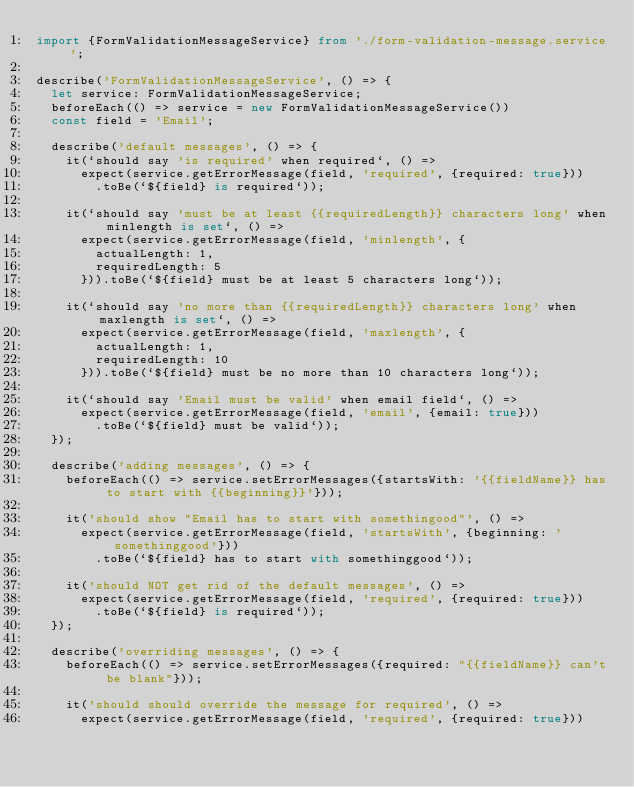<code> <loc_0><loc_0><loc_500><loc_500><_TypeScript_>import {FormValidationMessageService} from './form-validation-message.service';

describe('FormValidationMessageService', () => {
  let service: FormValidationMessageService;
  beforeEach(() => service = new FormValidationMessageService())
  const field = 'Email';

  describe('default messages', () => {
    it(`should say 'is required' when required`, () =>
      expect(service.getErrorMessage(field, 'required', {required: true}))
        .toBe(`${field} is required`));

    it(`should say 'must be at least {{requiredLength}} characters long' when minlength is set`, () =>
      expect(service.getErrorMessage(field, 'minlength', {
        actualLength: 1,
        requiredLength: 5
      })).toBe(`${field} must be at least 5 characters long`));

    it(`should say 'no more than {{requiredLength}} characters long' when maxlength is set`, () =>
      expect(service.getErrorMessage(field, 'maxlength', {
        actualLength: 1,
        requiredLength: 10
      })).toBe(`${field} must be no more than 10 characters long`));

    it(`should say 'Email must be valid' when email field`, () =>
      expect(service.getErrorMessage(field, 'email', {email: true}))
        .toBe(`${field} must be valid`));
  });

  describe('adding messages', () => {
    beforeEach(() => service.setErrorMessages({startsWith: '{{fieldName}} has to start with {{beginning}}'}));

    it('should show "Email has to start with somethingood"', () =>
      expect(service.getErrorMessage(field, 'startsWith', {beginning: 'somethinggood'}))
        .toBe(`${field} has to start with somethinggood`));

    it('should NOT get rid of the default messages', () =>
      expect(service.getErrorMessage(field, 'required', {required: true}))
        .toBe(`${field} is required`));
  });

  describe('overriding messages', () => {
    beforeEach(() => service.setErrorMessages({required: "{{fieldName}} can't be blank"}));

    it('should should override the message for required', () =>
      expect(service.getErrorMessage(field, 'required', {required: true}))</code> 